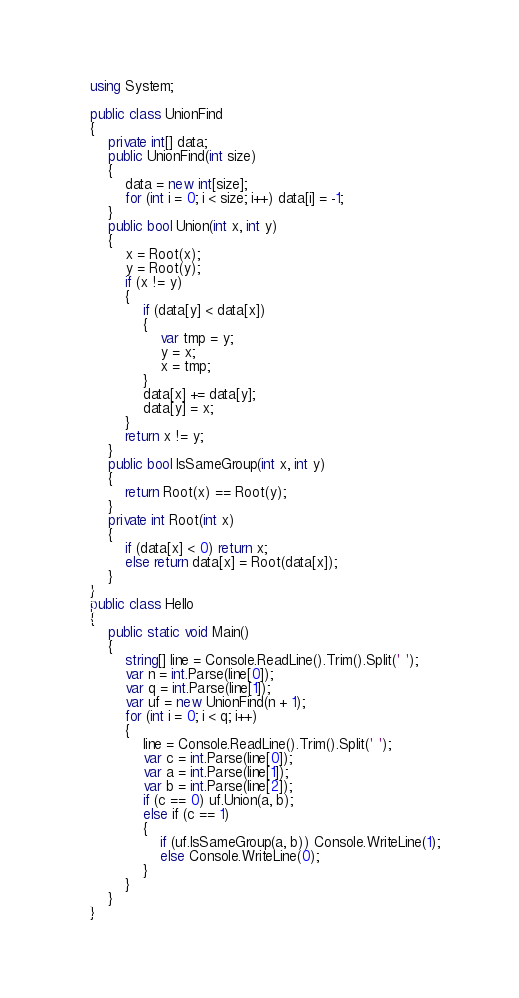Convert code to text. <code><loc_0><loc_0><loc_500><loc_500><_C#_>using System;

public class UnionFind
{
    private int[] data;
    public UnionFind(int size)
    {
        data = new int[size];
        for (int i = 0; i < size; i++) data[i] = -1;
    }
    public bool Union(int x, int y)
    {
        x = Root(x);
        y = Root(y);
        if (x != y)
        {
            if (data[y] < data[x])
            {
                var tmp = y;
                y = x;
                x = tmp;
            }
            data[x] += data[y];
            data[y] = x;
        }
        return x != y;
    }
    public bool IsSameGroup(int x, int y)
    {
        return Root(x) == Root(y);
    }
    private int Root(int x)
    {
        if (data[x] < 0) return x;
        else return data[x] = Root(data[x]);
    }
}
public class Hello
{
    public static void Main()
    {
        string[] line = Console.ReadLine().Trim().Split(' ');
        var n = int.Parse(line[0]);
        var q = int.Parse(line[1]);
        var uf = new UnionFind(n + 1);
        for (int i = 0; i < q; i++)
        {
            line = Console.ReadLine().Trim().Split(' ');
            var c = int.Parse(line[0]);
            var a = int.Parse(line[1]);
            var b = int.Parse(line[2]);
            if (c == 0) uf.Union(a, b);
            else if (c == 1)
            {
                if (uf.IsSameGroup(a, b)) Console.WriteLine(1);
                else Console.WriteLine(0);
            }
        }
    }
}

</code> 